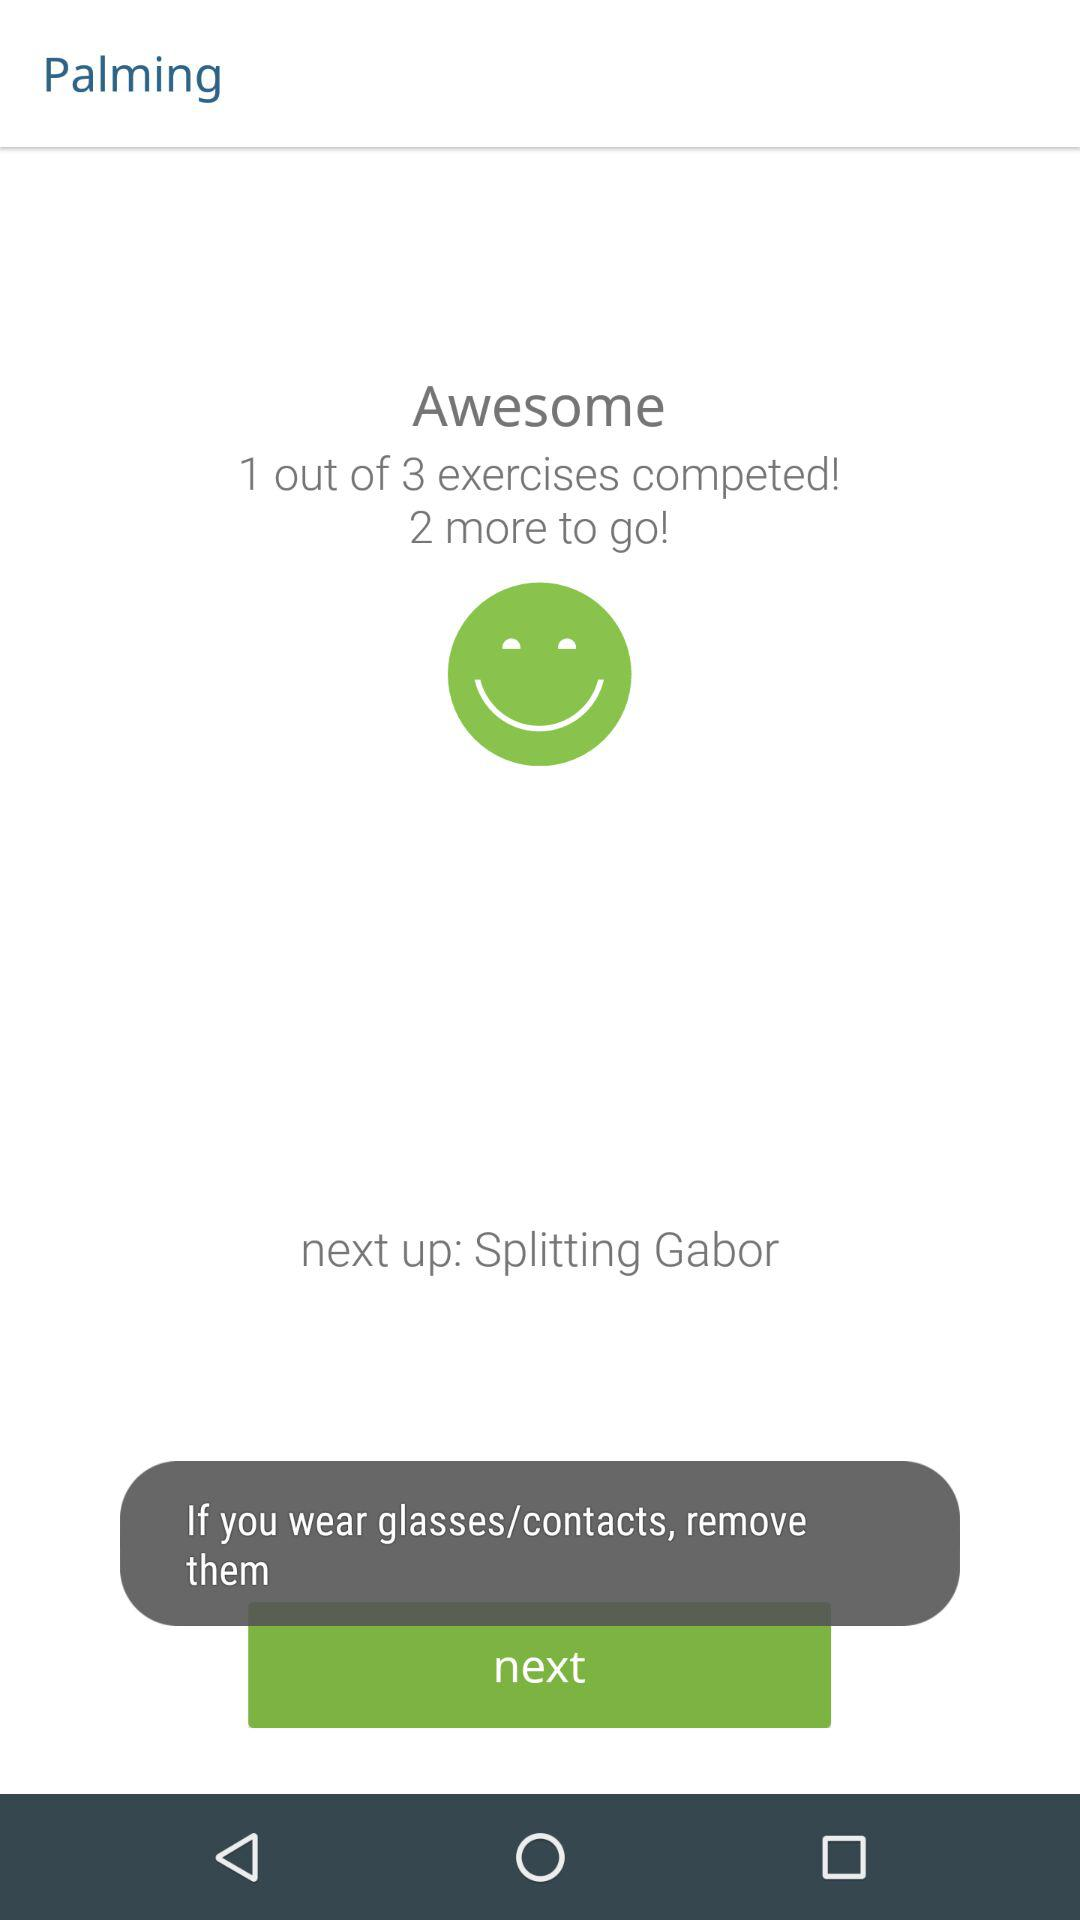What's the number of completed exercises? The number of completed exercises is 1. 